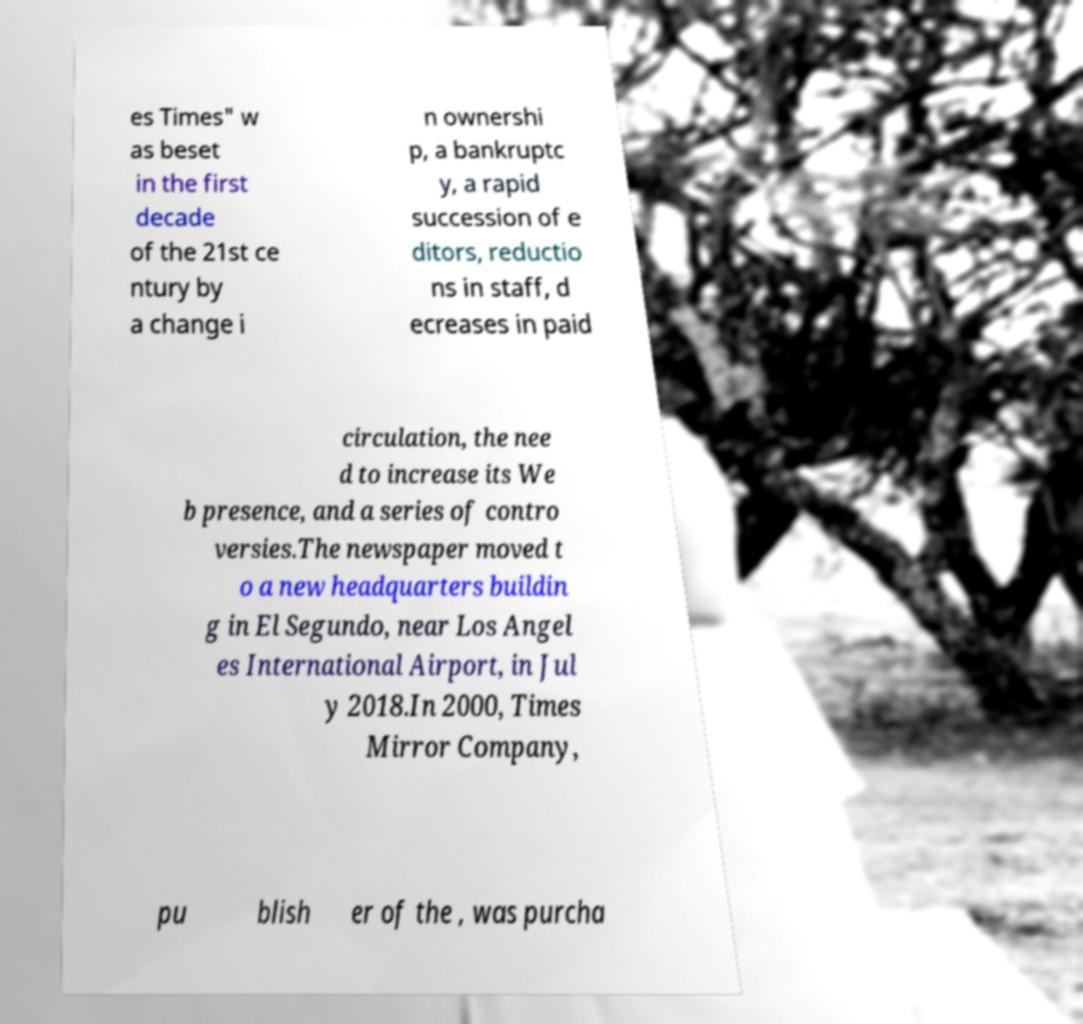Could you extract and type out the text from this image? es Times" w as beset in the first decade of the 21st ce ntury by a change i n ownershi p, a bankruptc y, a rapid succession of e ditors, reductio ns in staff, d ecreases in paid circulation, the nee d to increase its We b presence, and a series of contro versies.The newspaper moved t o a new headquarters buildin g in El Segundo, near Los Angel es International Airport, in Jul y 2018.In 2000, Times Mirror Company, pu blish er of the , was purcha 